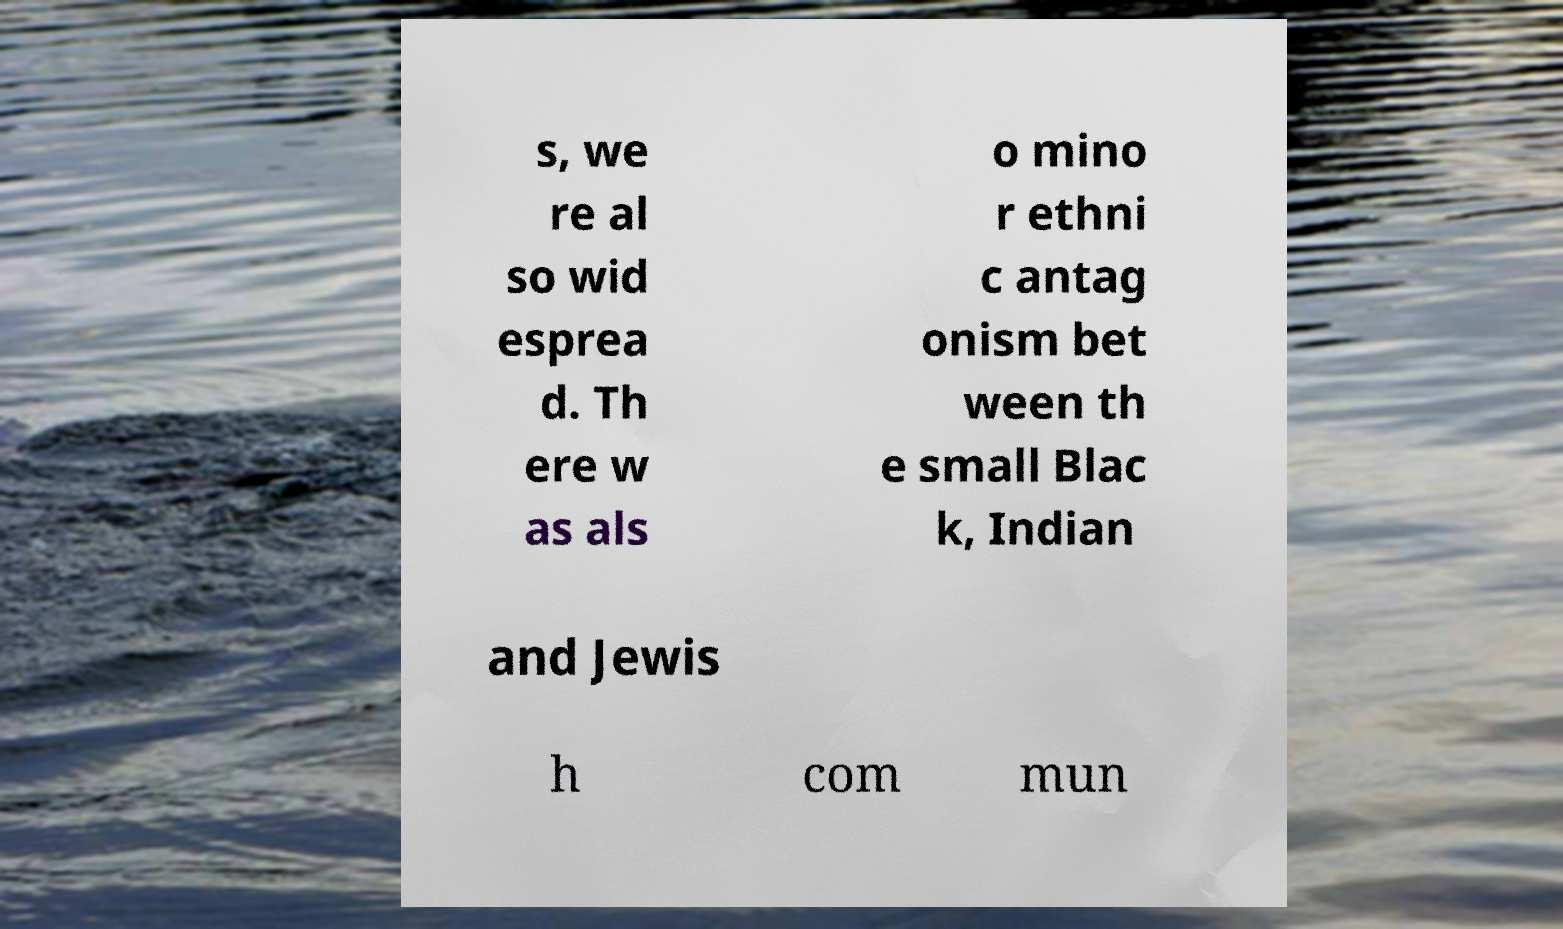I need the written content from this picture converted into text. Can you do that? s, we re al so wid esprea d. Th ere w as als o mino r ethni c antag onism bet ween th e small Blac k, Indian and Jewis h com mun 